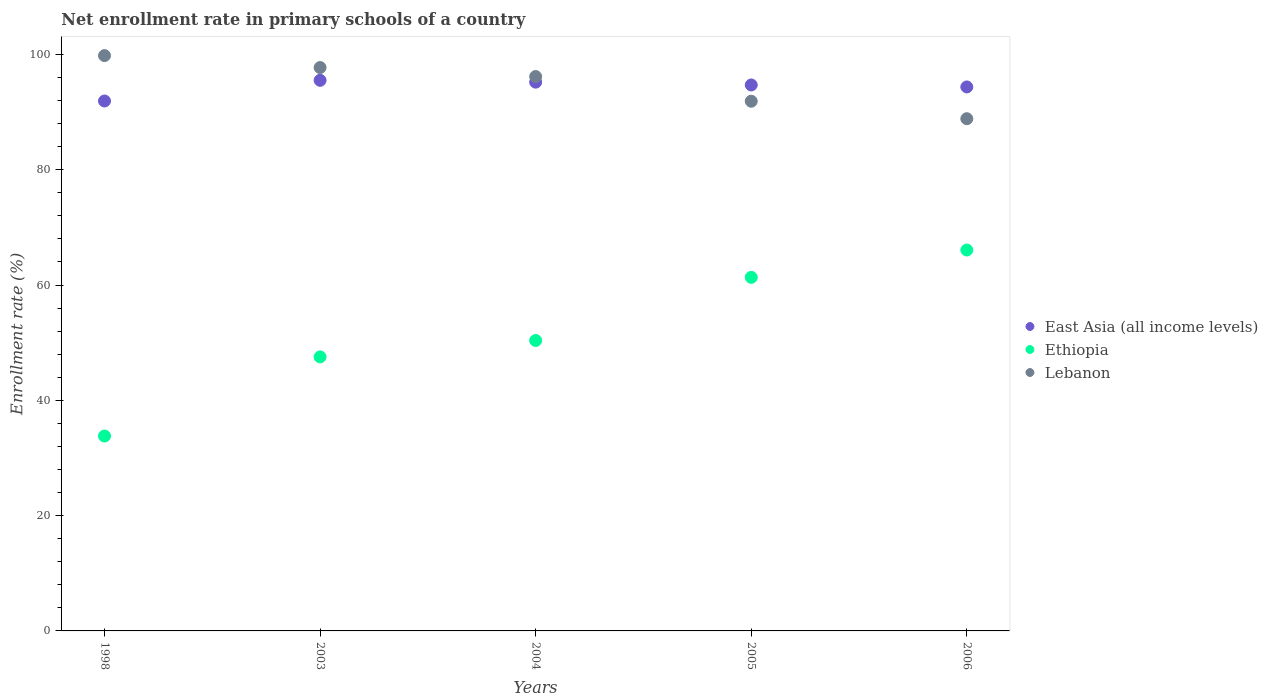What is the enrollment rate in primary schools in Lebanon in 2003?
Your answer should be compact. 97.72. Across all years, what is the maximum enrollment rate in primary schools in East Asia (all income levels)?
Your answer should be compact. 95.51. Across all years, what is the minimum enrollment rate in primary schools in Lebanon?
Keep it short and to the point. 88.85. In which year was the enrollment rate in primary schools in East Asia (all income levels) maximum?
Ensure brevity in your answer.  2003. What is the total enrollment rate in primary schools in Ethiopia in the graph?
Your answer should be very brief. 259.12. What is the difference between the enrollment rate in primary schools in Lebanon in 1998 and that in 2004?
Your answer should be compact. 3.63. What is the difference between the enrollment rate in primary schools in Ethiopia in 1998 and the enrollment rate in primary schools in East Asia (all income levels) in 2003?
Offer a very short reply. -61.7. What is the average enrollment rate in primary schools in Ethiopia per year?
Offer a very short reply. 51.82. In the year 2003, what is the difference between the enrollment rate in primary schools in Ethiopia and enrollment rate in primary schools in Lebanon?
Your answer should be compact. -50.19. What is the ratio of the enrollment rate in primary schools in Lebanon in 1998 to that in 2006?
Keep it short and to the point. 1.12. Is the enrollment rate in primary schools in Lebanon in 2004 less than that in 2006?
Your answer should be compact. No. Is the difference between the enrollment rate in primary schools in Ethiopia in 2003 and 2006 greater than the difference between the enrollment rate in primary schools in Lebanon in 2003 and 2006?
Provide a succinct answer. No. What is the difference between the highest and the second highest enrollment rate in primary schools in Ethiopia?
Give a very brief answer. 4.74. What is the difference between the highest and the lowest enrollment rate in primary schools in Ethiopia?
Offer a very short reply. 32.27. In how many years, is the enrollment rate in primary schools in Ethiopia greater than the average enrollment rate in primary schools in Ethiopia taken over all years?
Your answer should be compact. 2. Is the sum of the enrollment rate in primary schools in Ethiopia in 2003 and 2005 greater than the maximum enrollment rate in primary schools in Lebanon across all years?
Ensure brevity in your answer.  Yes. Does the enrollment rate in primary schools in East Asia (all income levels) monotonically increase over the years?
Keep it short and to the point. No. Is the enrollment rate in primary schools in Ethiopia strictly less than the enrollment rate in primary schools in Lebanon over the years?
Provide a succinct answer. Yes. What is the difference between two consecutive major ticks on the Y-axis?
Keep it short and to the point. 20. Does the graph contain any zero values?
Your response must be concise. No. Does the graph contain grids?
Ensure brevity in your answer.  No. Where does the legend appear in the graph?
Offer a terse response. Center right. How are the legend labels stacked?
Offer a terse response. Vertical. What is the title of the graph?
Your answer should be compact. Net enrollment rate in primary schools of a country. Does "Peru" appear as one of the legend labels in the graph?
Provide a succinct answer. No. What is the label or title of the Y-axis?
Make the answer very short. Enrollment rate (%). What is the Enrollment rate (%) in East Asia (all income levels) in 1998?
Your answer should be compact. 91.92. What is the Enrollment rate (%) in Ethiopia in 1998?
Offer a very short reply. 33.81. What is the Enrollment rate (%) of Lebanon in 1998?
Provide a short and direct response. 99.8. What is the Enrollment rate (%) in East Asia (all income levels) in 2003?
Offer a very short reply. 95.51. What is the Enrollment rate (%) in Ethiopia in 2003?
Your answer should be very brief. 47.53. What is the Enrollment rate (%) of Lebanon in 2003?
Your response must be concise. 97.72. What is the Enrollment rate (%) in East Asia (all income levels) in 2004?
Offer a terse response. 95.19. What is the Enrollment rate (%) in Ethiopia in 2004?
Your answer should be very brief. 50.38. What is the Enrollment rate (%) of Lebanon in 2004?
Keep it short and to the point. 96.16. What is the Enrollment rate (%) in East Asia (all income levels) in 2005?
Your answer should be compact. 94.7. What is the Enrollment rate (%) in Ethiopia in 2005?
Keep it short and to the point. 61.33. What is the Enrollment rate (%) in Lebanon in 2005?
Offer a very short reply. 91.88. What is the Enrollment rate (%) of East Asia (all income levels) in 2006?
Provide a succinct answer. 94.36. What is the Enrollment rate (%) of Ethiopia in 2006?
Your answer should be compact. 66.07. What is the Enrollment rate (%) of Lebanon in 2006?
Provide a succinct answer. 88.85. Across all years, what is the maximum Enrollment rate (%) in East Asia (all income levels)?
Offer a very short reply. 95.51. Across all years, what is the maximum Enrollment rate (%) in Ethiopia?
Offer a very short reply. 66.07. Across all years, what is the maximum Enrollment rate (%) in Lebanon?
Your answer should be very brief. 99.8. Across all years, what is the minimum Enrollment rate (%) in East Asia (all income levels)?
Offer a terse response. 91.92. Across all years, what is the minimum Enrollment rate (%) of Ethiopia?
Keep it short and to the point. 33.81. Across all years, what is the minimum Enrollment rate (%) of Lebanon?
Offer a very short reply. 88.85. What is the total Enrollment rate (%) in East Asia (all income levels) in the graph?
Offer a terse response. 471.67. What is the total Enrollment rate (%) in Ethiopia in the graph?
Your answer should be very brief. 259.12. What is the total Enrollment rate (%) of Lebanon in the graph?
Your answer should be very brief. 474.41. What is the difference between the Enrollment rate (%) of East Asia (all income levels) in 1998 and that in 2003?
Ensure brevity in your answer.  -3.59. What is the difference between the Enrollment rate (%) in Ethiopia in 1998 and that in 2003?
Your answer should be compact. -13.73. What is the difference between the Enrollment rate (%) in Lebanon in 1998 and that in 2003?
Your answer should be compact. 2.07. What is the difference between the Enrollment rate (%) of East Asia (all income levels) in 1998 and that in 2004?
Make the answer very short. -3.27. What is the difference between the Enrollment rate (%) of Ethiopia in 1998 and that in 2004?
Provide a succinct answer. -16.57. What is the difference between the Enrollment rate (%) in Lebanon in 1998 and that in 2004?
Your answer should be very brief. 3.63. What is the difference between the Enrollment rate (%) of East Asia (all income levels) in 1998 and that in 2005?
Offer a very short reply. -2.78. What is the difference between the Enrollment rate (%) of Ethiopia in 1998 and that in 2005?
Provide a short and direct response. -27.52. What is the difference between the Enrollment rate (%) of Lebanon in 1998 and that in 2005?
Your answer should be very brief. 7.92. What is the difference between the Enrollment rate (%) in East Asia (all income levels) in 1998 and that in 2006?
Make the answer very short. -2.44. What is the difference between the Enrollment rate (%) in Ethiopia in 1998 and that in 2006?
Offer a very short reply. -32.27. What is the difference between the Enrollment rate (%) of Lebanon in 1998 and that in 2006?
Your answer should be compact. 10.95. What is the difference between the Enrollment rate (%) of East Asia (all income levels) in 2003 and that in 2004?
Make the answer very short. 0.32. What is the difference between the Enrollment rate (%) in Ethiopia in 2003 and that in 2004?
Your answer should be compact. -2.84. What is the difference between the Enrollment rate (%) of Lebanon in 2003 and that in 2004?
Offer a very short reply. 1.56. What is the difference between the Enrollment rate (%) in East Asia (all income levels) in 2003 and that in 2005?
Your answer should be compact. 0.8. What is the difference between the Enrollment rate (%) in Ethiopia in 2003 and that in 2005?
Offer a terse response. -13.8. What is the difference between the Enrollment rate (%) in Lebanon in 2003 and that in 2005?
Make the answer very short. 5.84. What is the difference between the Enrollment rate (%) in East Asia (all income levels) in 2003 and that in 2006?
Your answer should be compact. 1.15. What is the difference between the Enrollment rate (%) in Ethiopia in 2003 and that in 2006?
Your answer should be compact. -18.54. What is the difference between the Enrollment rate (%) in Lebanon in 2003 and that in 2006?
Provide a succinct answer. 8.87. What is the difference between the Enrollment rate (%) of East Asia (all income levels) in 2004 and that in 2005?
Your answer should be very brief. 0.49. What is the difference between the Enrollment rate (%) of Ethiopia in 2004 and that in 2005?
Make the answer very short. -10.95. What is the difference between the Enrollment rate (%) in Lebanon in 2004 and that in 2005?
Give a very brief answer. 4.28. What is the difference between the Enrollment rate (%) in East Asia (all income levels) in 2004 and that in 2006?
Provide a succinct answer. 0.83. What is the difference between the Enrollment rate (%) of Ethiopia in 2004 and that in 2006?
Provide a succinct answer. -15.69. What is the difference between the Enrollment rate (%) of Lebanon in 2004 and that in 2006?
Provide a succinct answer. 7.31. What is the difference between the Enrollment rate (%) of East Asia (all income levels) in 2005 and that in 2006?
Your response must be concise. 0.34. What is the difference between the Enrollment rate (%) in Ethiopia in 2005 and that in 2006?
Make the answer very short. -4.74. What is the difference between the Enrollment rate (%) of Lebanon in 2005 and that in 2006?
Make the answer very short. 3.03. What is the difference between the Enrollment rate (%) in East Asia (all income levels) in 1998 and the Enrollment rate (%) in Ethiopia in 2003?
Your answer should be compact. 44.39. What is the difference between the Enrollment rate (%) in East Asia (all income levels) in 1998 and the Enrollment rate (%) in Lebanon in 2003?
Ensure brevity in your answer.  -5.8. What is the difference between the Enrollment rate (%) of Ethiopia in 1998 and the Enrollment rate (%) of Lebanon in 2003?
Provide a short and direct response. -63.92. What is the difference between the Enrollment rate (%) of East Asia (all income levels) in 1998 and the Enrollment rate (%) of Ethiopia in 2004?
Offer a very short reply. 41.54. What is the difference between the Enrollment rate (%) in East Asia (all income levels) in 1998 and the Enrollment rate (%) in Lebanon in 2004?
Your response must be concise. -4.24. What is the difference between the Enrollment rate (%) in Ethiopia in 1998 and the Enrollment rate (%) in Lebanon in 2004?
Provide a succinct answer. -62.36. What is the difference between the Enrollment rate (%) of East Asia (all income levels) in 1998 and the Enrollment rate (%) of Ethiopia in 2005?
Keep it short and to the point. 30.59. What is the difference between the Enrollment rate (%) in East Asia (all income levels) in 1998 and the Enrollment rate (%) in Lebanon in 2005?
Ensure brevity in your answer.  0.04. What is the difference between the Enrollment rate (%) of Ethiopia in 1998 and the Enrollment rate (%) of Lebanon in 2005?
Keep it short and to the point. -58.07. What is the difference between the Enrollment rate (%) in East Asia (all income levels) in 1998 and the Enrollment rate (%) in Ethiopia in 2006?
Provide a succinct answer. 25.85. What is the difference between the Enrollment rate (%) of East Asia (all income levels) in 1998 and the Enrollment rate (%) of Lebanon in 2006?
Keep it short and to the point. 3.07. What is the difference between the Enrollment rate (%) in Ethiopia in 1998 and the Enrollment rate (%) in Lebanon in 2006?
Offer a terse response. -55.04. What is the difference between the Enrollment rate (%) of East Asia (all income levels) in 2003 and the Enrollment rate (%) of Ethiopia in 2004?
Your answer should be very brief. 45.13. What is the difference between the Enrollment rate (%) of East Asia (all income levels) in 2003 and the Enrollment rate (%) of Lebanon in 2004?
Offer a terse response. -0.66. What is the difference between the Enrollment rate (%) of Ethiopia in 2003 and the Enrollment rate (%) of Lebanon in 2004?
Keep it short and to the point. -48.63. What is the difference between the Enrollment rate (%) in East Asia (all income levels) in 2003 and the Enrollment rate (%) in Ethiopia in 2005?
Offer a terse response. 34.18. What is the difference between the Enrollment rate (%) in East Asia (all income levels) in 2003 and the Enrollment rate (%) in Lebanon in 2005?
Your response must be concise. 3.63. What is the difference between the Enrollment rate (%) of Ethiopia in 2003 and the Enrollment rate (%) of Lebanon in 2005?
Your response must be concise. -44.35. What is the difference between the Enrollment rate (%) of East Asia (all income levels) in 2003 and the Enrollment rate (%) of Ethiopia in 2006?
Make the answer very short. 29.43. What is the difference between the Enrollment rate (%) in East Asia (all income levels) in 2003 and the Enrollment rate (%) in Lebanon in 2006?
Give a very brief answer. 6.66. What is the difference between the Enrollment rate (%) of Ethiopia in 2003 and the Enrollment rate (%) of Lebanon in 2006?
Your response must be concise. -41.32. What is the difference between the Enrollment rate (%) of East Asia (all income levels) in 2004 and the Enrollment rate (%) of Ethiopia in 2005?
Provide a short and direct response. 33.86. What is the difference between the Enrollment rate (%) in East Asia (all income levels) in 2004 and the Enrollment rate (%) in Lebanon in 2005?
Give a very brief answer. 3.31. What is the difference between the Enrollment rate (%) in Ethiopia in 2004 and the Enrollment rate (%) in Lebanon in 2005?
Offer a very short reply. -41.5. What is the difference between the Enrollment rate (%) in East Asia (all income levels) in 2004 and the Enrollment rate (%) in Ethiopia in 2006?
Offer a terse response. 29.12. What is the difference between the Enrollment rate (%) of East Asia (all income levels) in 2004 and the Enrollment rate (%) of Lebanon in 2006?
Your answer should be very brief. 6.34. What is the difference between the Enrollment rate (%) of Ethiopia in 2004 and the Enrollment rate (%) of Lebanon in 2006?
Give a very brief answer. -38.47. What is the difference between the Enrollment rate (%) of East Asia (all income levels) in 2005 and the Enrollment rate (%) of Ethiopia in 2006?
Make the answer very short. 28.63. What is the difference between the Enrollment rate (%) of East Asia (all income levels) in 2005 and the Enrollment rate (%) of Lebanon in 2006?
Make the answer very short. 5.85. What is the difference between the Enrollment rate (%) in Ethiopia in 2005 and the Enrollment rate (%) in Lebanon in 2006?
Your answer should be compact. -27.52. What is the average Enrollment rate (%) of East Asia (all income levels) per year?
Provide a short and direct response. 94.33. What is the average Enrollment rate (%) in Ethiopia per year?
Your response must be concise. 51.82. What is the average Enrollment rate (%) of Lebanon per year?
Your answer should be compact. 94.88. In the year 1998, what is the difference between the Enrollment rate (%) of East Asia (all income levels) and Enrollment rate (%) of Ethiopia?
Your answer should be very brief. 58.11. In the year 1998, what is the difference between the Enrollment rate (%) in East Asia (all income levels) and Enrollment rate (%) in Lebanon?
Offer a terse response. -7.88. In the year 1998, what is the difference between the Enrollment rate (%) in Ethiopia and Enrollment rate (%) in Lebanon?
Your answer should be very brief. -65.99. In the year 2003, what is the difference between the Enrollment rate (%) of East Asia (all income levels) and Enrollment rate (%) of Ethiopia?
Your answer should be compact. 47.97. In the year 2003, what is the difference between the Enrollment rate (%) of East Asia (all income levels) and Enrollment rate (%) of Lebanon?
Keep it short and to the point. -2.22. In the year 2003, what is the difference between the Enrollment rate (%) of Ethiopia and Enrollment rate (%) of Lebanon?
Give a very brief answer. -50.19. In the year 2004, what is the difference between the Enrollment rate (%) in East Asia (all income levels) and Enrollment rate (%) in Ethiopia?
Give a very brief answer. 44.81. In the year 2004, what is the difference between the Enrollment rate (%) of East Asia (all income levels) and Enrollment rate (%) of Lebanon?
Ensure brevity in your answer.  -0.97. In the year 2004, what is the difference between the Enrollment rate (%) of Ethiopia and Enrollment rate (%) of Lebanon?
Make the answer very short. -45.78. In the year 2005, what is the difference between the Enrollment rate (%) of East Asia (all income levels) and Enrollment rate (%) of Ethiopia?
Provide a succinct answer. 33.37. In the year 2005, what is the difference between the Enrollment rate (%) of East Asia (all income levels) and Enrollment rate (%) of Lebanon?
Your answer should be compact. 2.82. In the year 2005, what is the difference between the Enrollment rate (%) of Ethiopia and Enrollment rate (%) of Lebanon?
Make the answer very short. -30.55. In the year 2006, what is the difference between the Enrollment rate (%) in East Asia (all income levels) and Enrollment rate (%) in Ethiopia?
Offer a very short reply. 28.29. In the year 2006, what is the difference between the Enrollment rate (%) in East Asia (all income levels) and Enrollment rate (%) in Lebanon?
Your answer should be very brief. 5.51. In the year 2006, what is the difference between the Enrollment rate (%) in Ethiopia and Enrollment rate (%) in Lebanon?
Provide a short and direct response. -22.78. What is the ratio of the Enrollment rate (%) of East Asia (all income levels) in 1998 to that in 2003?
Your answer should be very brief. 0.96. What is the ratio of the Enrollment rate (%) in Ethiopia in 1998 to that in 2003?
Give a very brief answer. 0.71. What is the ratio of the Enrollment rate (%) of Lebanon in 1998 to that in 2003?
Keep it short and to the point. 1.02. What is the ratio of the Enrollment rate (%) in East Asia (all income levels) in 1998 to that in 2004?
Provide a short and direct response. 0.97. What is the ratio of the Enrollment rate (%) of Ethiopia in 1998 to that in 2004?
Give a very brief answer. 0.67. What is the ratio of the Enrollment rate (%) of Lebanon in 1998 to that in 2004?
Offer a very short reply. 1.04. What is the ratio of the Enrollment rate (%) of East Asia (all income levels) in 1998 to that in 2005?
Provide a short and direct response. 0.97. What is the ratio of the Enrollment rate (%) of Ethiopia in 1998 to that in 2005?
Your response must be concise. 0.55. What is the ratio of the Enrollment rate (%) in Lebanon in 1998 to that in 2005?
Provide a succinct answer. 1.09. What is the ratio of the Enrollment rate (%) in East Asia (all income levels) in 1998 to that in 2006?
Offer a terse response. 0.97. What is the ratio of the Enrollment rate (%) of Ethiopia in 1998 to that in 2006?
Make the answer very short. 0.51. What is the ratio of the Enrollment rate (%) in Lebanon in 1998 to that in 2006?
Make the answer very short. 1.12. What is the ratio of the Enrollment rate (%) in Ethiopia in 2003 to that in 2004?
Your answer should be compact. 0.94. What is the ratio of the Enrollment rate (%) in Lebanon in 2003 to that in 2004?
Keep it short and to the point. 1.02. What is the ratio of the Enrollment rate (%) in East Asia (all income levels) in 2003 to that in 2005?
Offer a very short reply. 1.01. What is the ratio of the Enrollment rate (%) of Ethiopia in 2003 to that in 2005?
Your answer should be compact. 0.78. What is the ratio of the Enrollment rate (%) in Lebanon in 2003 to that in 2005?
Provide a succinct answer. 1.06. What is the ratio of the Enrollment rate (%) in East Asia (all income levels) in 2003 to that in 2006?
Keep it short and to the point. 1.01. What is the ratio of the Enrollment rate (%) of Ethiopia in 2003 to that in 2006?
Offer a terse response. 0.72. What is the ratio of the Enrollment rate (%) of Lebanon in 2003 to that in 2006?
Keep it short and to the point. 1.1. What is the ratio of the Enrollment rate (%) of Ethiopia in 2004 to that in 2005?
Your answer should be very brief. 0.82. What is the ratio of the Enrollment rate (%) of Lebanon in 2004 to that in 2005?
Your answer should be very brief. 1.05. What is the ratio of the Enrollment rate (%) in East Asia (all income levels) in 2004 to that in 2006?
Provide a short and direct response. 1.01. What is the ratio of the Enrollment rate (%) in Ethiopia in 2004 to that in 2006?
Offer a very short reply. 0.76. What is the ratio of the Enrollment rate (%) of Lebanon in 2004 to that in 2006?
Your answer should be compact. 1.08. What is the ratio of the Enrollment rate (%) in East Asia (all income levels) in 2005 to that in 2006?
Your response must be concise. 1. What is the ratio of the Enrollment rate (%) of Ethiopia in 2005 to that in 2006?
Ensure brevity in your answer.  0.93. What is the ratio of the Enrollment rate (%) in Lebanon in 2005 to that in 2006?
Keep it short and to the point. 1.03. What is the difference between the highest and the second highest Enrollment rate (%) of East Asia (all income levels)?
Your answer should be compact. 0.32. What is the difference between the highest and the second highest Enrollment rate (%) in Ethiopia?
Provide a short and direct response. 4.74. What is the difference between the highest and the second highest Enrollment rate (%) of Lebanon?
Your response must be concise. 2.07. What is the difference between the highest and the lowest Enrollment rate (%) in East Asia (all income levels)?
Give a very brief answer. 3.59. What is the difference between the highest and the lowest Enrollment rate (%) in Ethiopia?
Make the answer very short. 32.27. What is the difference between the highest and the lowest Enrollment rate (%) of Lebanon?
Give a very brief answer. 10.95. 